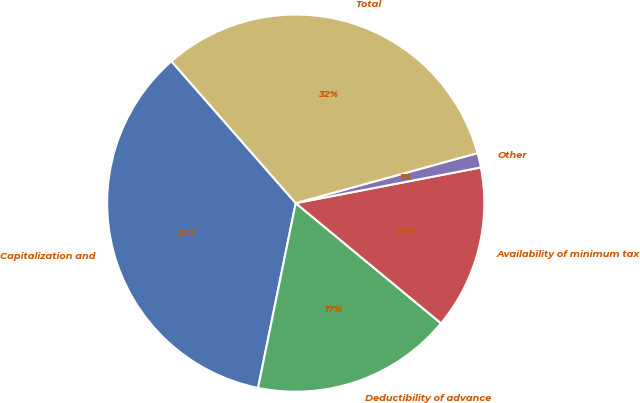Convert chart. <chart><loc_0><loc_0><loc_500><loc_500><pie_chart><fcel>Capitalization and<fcel>Deductibility of advance<fcel>Availability of minimum tax<fcel>Other<fcel>Total<nl><fcel>35.35%<fcel>17.2%<fcel>14.03%<fcel>1.24%<fcel>32.18%<nl></chart> 